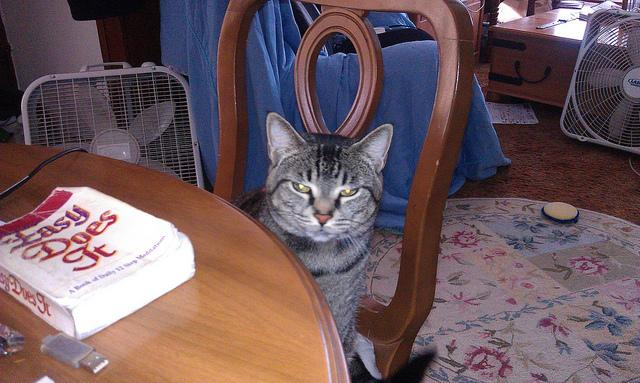The cat is sitting at a table with what featured on top of it? Please explain your reasoning. book. The cat is by the book. 